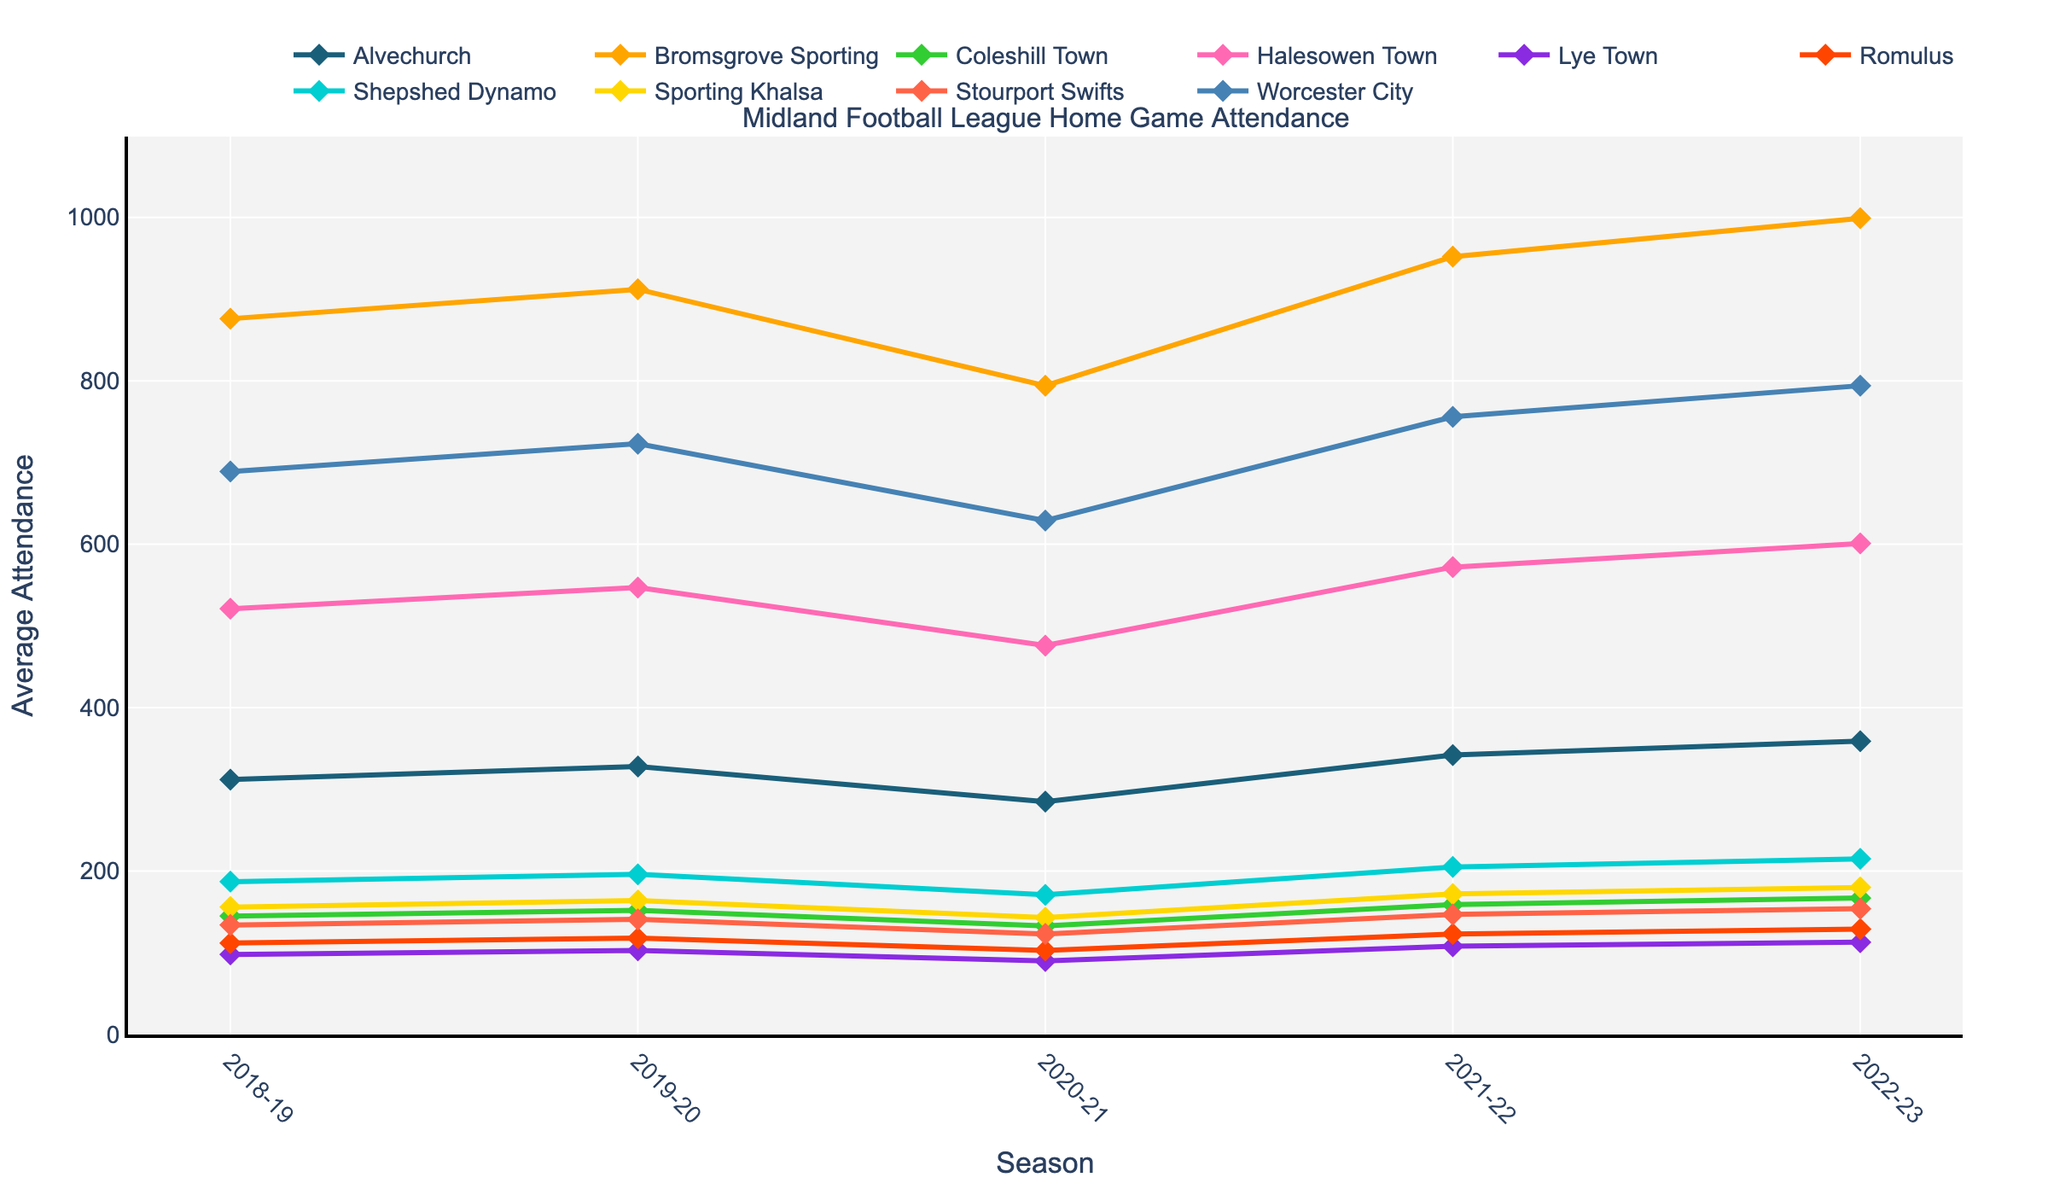Which club had the highest average attendance in the 2022-23 season? To determine the highest attendance for the 2022-23 season, we look at the attendance values for each club in that season. Bromsgrove Sporting had the highest value at 999.
Answer: Bromsgrove Sporting What is the total attendance for Halesowen Town over the 5 seasons? Adding the attendances for Halesowen Town across the 5 seasons (521 + 547 + 476 + 572 + 601) gives us a total of 2717.
Answer: 2717 Which two clubs had the most similar average attendances in the 2020-21 season? In the 2020-21 season, compare the attendances: Alvechurch (285), Bromsgrove Sporting (794), Coleshill Town (133), Halesowen Town (476), Lye Town (90), Romulus (103), Shepshed Dynamo (171), Sporting Khalsa (143), Stourport Swifts (123), Worcester City (629). Look for the smallest difference. Shepshed Dynamo (171) and Sporting Khalsa (143) have a difference of 28.
Answer: Shepshed Dynamo and Sporting Khalsa How did Worcester City's attendance trend change from 2018-19 to 2022-23? To find the trend, examine Worcester City's values over the five seasons: 689, 723, 629, 756, 794. The trend shows a general increase with a slight dip in the 2020-21 season.
Answer: Increasing trend Which season showed the greatest increase in attendance for Romulus? Find the difference between consecutive seasons for Romulus: 2018-19 to 2019-20 (118-112=6), 2019-20 to 2020-21 (103-118=-15), 2020-21 to 2021-22 (123-103=20), 2021-22 to 2022-23 (129-123=6). The greatest increase is from 2020-21 to 2021-22 (+20).
Answer: 2020-21 to 2021-22 What was the average attendance for Bromsgrove Sporting over the last 5 years? Sum the attendances for Bromsgrove Sporting over the 5 seasons (876 + 912 + 794 + 952 + 999) to get 4533. Divide by 5 for the average: 4533 / 5 = 906.6.
Answer: 906.6 Which club had the lowest average attendance in the 2019-20 season? To find the club with the lowest attendance in 2019-20, compare the values: Alvechurch (328), Bromsgrove Sporting (912), Coleshill Town (152), Halesowen Town (547), Lye Town (103), Romulus (118), Shepshed Dynamo (196), Sporting Khalsa (164), Stourport Swifts (141), Worcester City (723). Lye Town has the lowest at 103.
Answer: Lye Town 